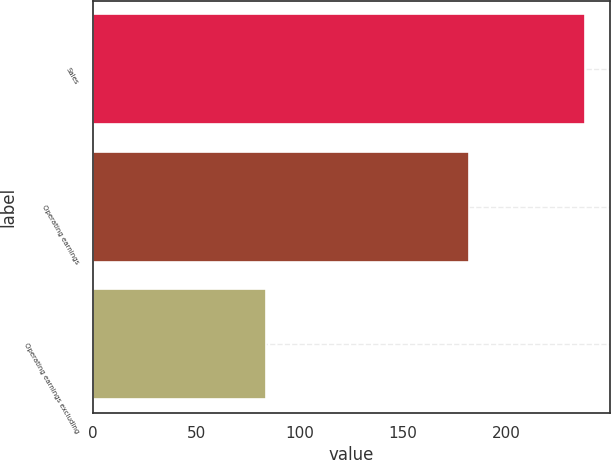<chart> <loc_0><loc_0><loc_500><loc_500><bar_chart><fcel>Sales<fcel>Operating earnings<fcel>Operating earnings excluding<nl><fcel>238<fcel>182<fcel>84<nl></chart> 